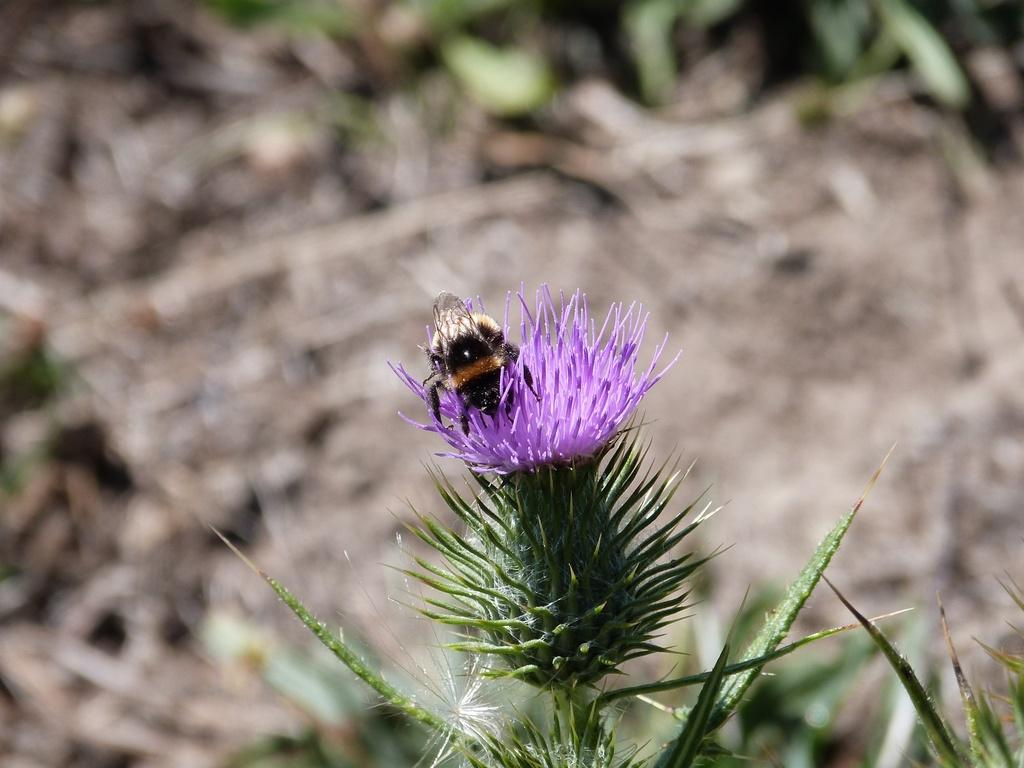What is present in the image? There is a fly in the image. What is the fly located on? The fly is on a carthamus plant. How many chairs can be seen in the image? There are no chairs present in the image. What type of pizzas are being pushed in the image? There are no pizzas or pushing actions present in the image. 